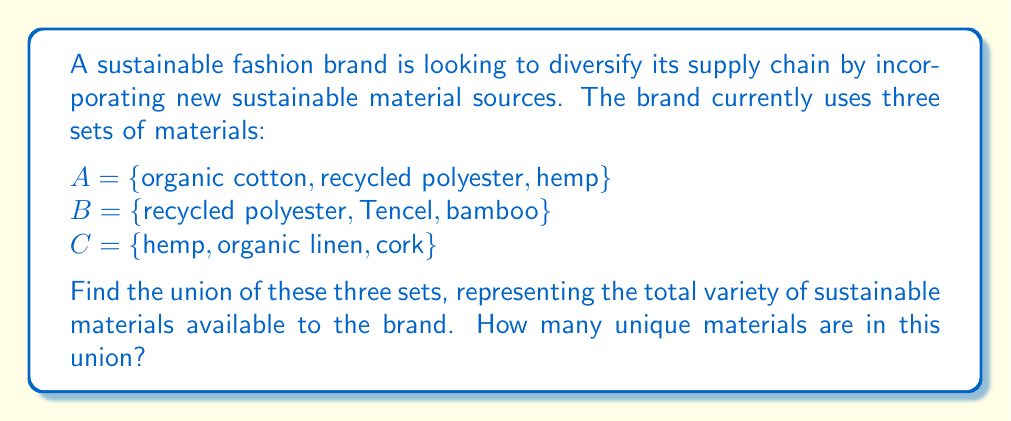Show me your answer to this math problem. To solve this problem, we need to find the union of sets A, B, and C, denoted as $A \cup B \cup C$. The union of these sets will include all unique elements from each set, without duplicates.

Let's follow these steps:

1. List all elements from set A:
   {organic cotton, recycled polyester, hemp}

2. Add unique elements from set B:
   Tencel and bamboo are new, but recycled polyester is already included.
   {organic cotton, recycled polyester, hemp, Tencel, bamboo}

3. Add unique elements from set C:
   organic linen and cork are new, but hemp is already included.
   {organic cotton, recycled polyester, hemp, Tencel, bamboo, organic linen, cork}

4. Count the number of unique elements in the resulting set:
   There are 7 unique elements in the union.

Mathematically, we can express this as:

$$A \cup B \cup C = \{x : x \in A \text{ or } x \in B \text{ or } x \in C\}$$

The resulting set represents all sustainable materials available to the brand from these three sources, providing a wider range of options for their supply chain.
Answer: $A \cup B \cup C = \{\text{organic cotton, recycled polyester, hemp, Tencel, bamboo, organic linen, cork}\}$

The union contains 7 unique sustainable materials. 